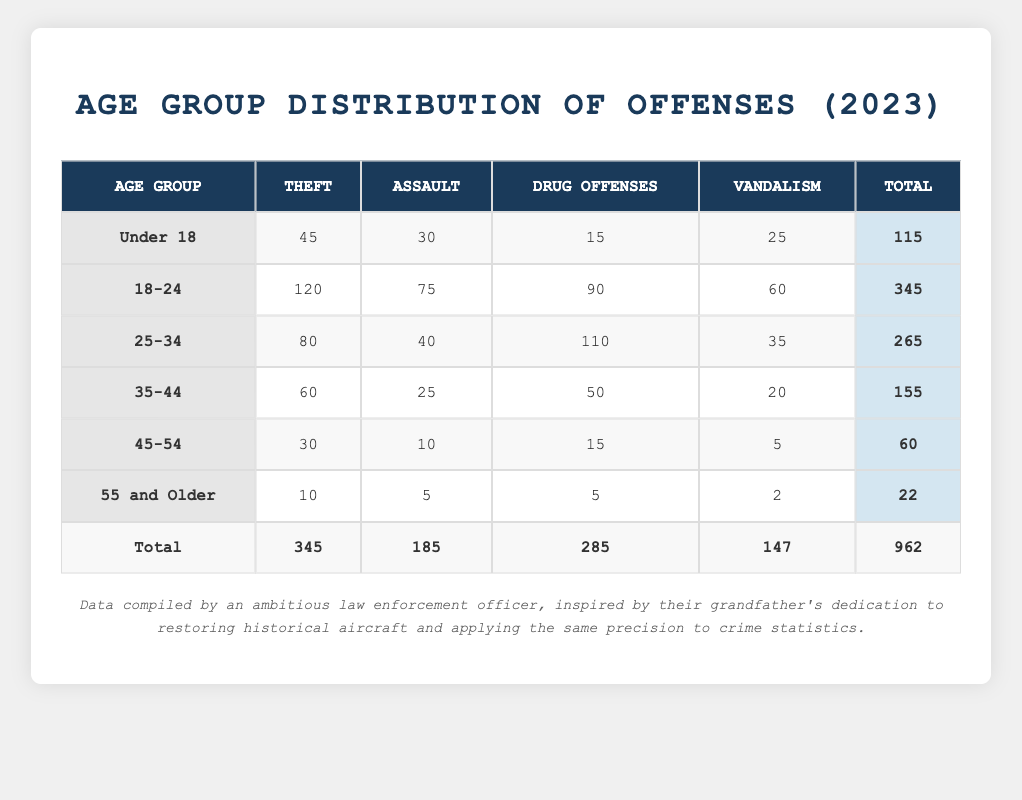What is the total number of individuals charged with Assault in the 18-24 age group? To find the total number of individuals charged with Assault in the 18-24 age group, refer to the table under the "Assault" column and locate the row for the "18-24" age group. The value listed is 75.
Answer: 75 Which age group has the highest total number of charges? Look at the "Total" column at the bottom of each age group to find the highest value. The "18-24" age group has the highest total, listed as 345.
Answer: 18-24 How many more individuals were charged with Theft than Vandalism in the 25-34 age group? First, find the number of Theft charges (80) and Vandalism charges (35) for the 25-34 age group. Then, calculate the difference: 80 - 35 = 45.
Answer: 45 Is it true that the number of individuals charged with Drug Offenses in the Under 18 age group is greater than those charged with Vandalism? Compare the values in the respective rows: Drug Offenses (15) and Vandalism (25) for the Under 18 age group. Since 15 is less than 25, the statement is false.
Answer: No What percentage of the total charges did individuals aged 55 and older account for? First, calculate the total charges for the 55 and older age group, which is 22. Then, find the grand total of all charges, which is 962. The percentage is calculated as (22/962) * 100 = approximately 2.29%.
Answer: 2.29% 